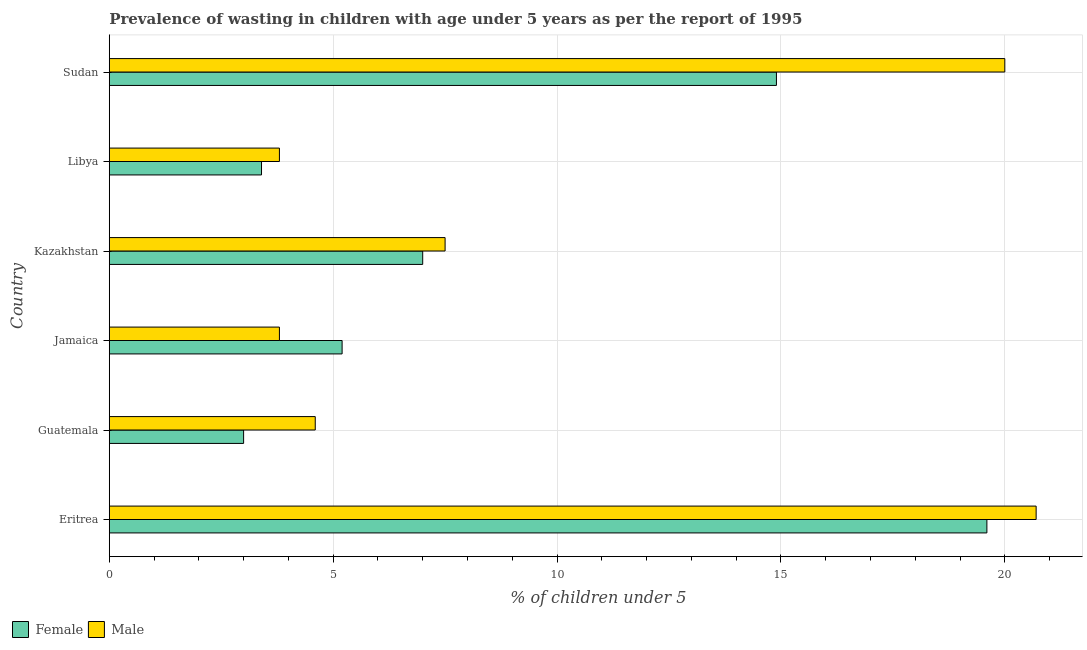Are the number of bars on each tick of the Y-axis equal?
Provide a succinct answer. Yes. How many bars are there on the 6th tick from the bottom?
Provide a succinct answer. 2. What is the label of the 2nd group of bars from the top?
Your answer should be compact. Libya. What is the percentage of undernourished male children in Jamaica?
Give a very brief answer. 3.8. Across all countries, what is the maximum percentage of undernourished male children?
Provide a short and direct response. 20.7. Across all countries, what is the minimum percentage of undernourished male children?
Your answer should be compact. 3.8. In which country was the percentage of undernourished male children maximum?
Provide a succinct answer. Eritrea. In which country was the percentage of undernourished female children minimum?
Ensure brevity in your answer.  Guatemala. What is the total percentage of undernourished male children in the graph?
Ensure brevity in your answer.  60.4. What is the difference between the percentage of undernourished male children in Jamaica and that in Sudan?
Keep it short and to the point. -16.2. What is the difference between the percentage of undernourished male children in Sudan and the percentage of undernourished female children in Libya?
Your answer should be very brief. 16.6. What is the average percentage of undernourished male children per country?
Make the answer very short. 10.07. In how many countries, is the percentage of undernourished female children greater than 4 %?
Provide a succinct answer. 4. What is the ratio of the percentage of undernourished female children in Libya to that in Sudan?
Give a very brief answer. 0.23. Is the percentage of undernourished female children in Eritrea less than that in Kazakhstan?
Provide a short and direct response. No. What is the difference between the highest and the lowest percentage of undernourished female children?
Your answer should be very brief. 16.6. Is the sum of the percentage of undernourished male children in Jamaica and Kazakhstan greater than the maximum percentage of undernourished female children across all countries?
Your answer should be compact. No. Are all the bars in the graph horizontal?
Provide a succinct answer. Yes. How many countries are there in the graph?
Offer a very short reply. 6. What is the difference between two consecutive major ticks on the X-axis?
Keep it short and to the point. 5. Are the values on the major ticks of X-axis written in scientific E-notation?
Give a very brief answer. No. Does the graph contain any zero values?
Offer a very short reply. No. Does the graph contain grids?
Provide a short and direct response. Yes. How many legend labels are there?
Give a very brief answer. 2. How are the legend labels stacked?
Your response must be concise. Horizontal. What is the title of the graph?
Ensure brevity in your answer.  Prevalence of wasting in children with age under 5 years as per the report of 1995. What is the label or title of the X-axis?
Your answer should be compact.  % of children under 5. What is the  % of children under 5 in Female in Eritrea?
Offer a very short reply. 19.6. What is the  % of children under 5 of Male in Eritrea?
Offer a very short reply. 20.7. What is the  % of children under 5 in Female in Guatemala?
Make the answer very short. 3. What is the  % of children under 5 of Male in Guatemala?
Give a very brief answer. 4.6. What is the  % of children under 5 of Female in Jamaica?
Offer a very short reply. 5.2. What is the  % of children under 5 of Male in Jamaica?
Offer a very short reply. 3.8. What is the  % of children under 5 in Female in Libya?
Provide a short and direct response. 3.4. What is the  % of children under 5 in Male in Libya?
Give a very brief answer. 3.8. What is the  % of children under 5 of Female in Sudan?
Make the answer very short. 14.9. What is the  % of children under 5 of Male in Sudan?
Keep it short and to the point. 20. Across all countries, what is the maximum  % of children under 5 in Female?
Keep it short and to the point. 19.6. Across all countries, what is the maximum  % of children under 5 of Male?
Offer a terse response. 20.7. Across all countries, what is the minimum  % of children under 5 in Female?
Provide a succinct answer. 3. Across all countries, what is the minimum  % of children under 5 of Male?
Make the answer very short. 3.8. What is the total  % of children under 5 of Female in the graph?
Ensure brevity in your answer.  53.1. What is the total  % of children under 5 of Male in the graph?
Your answer should be very brief. 60.4. What is the difference between the  % of children under 5 in Female in Eritrea and that in Jamaica?
Give a very brief answer. 14.4. What is the difference between the  % of children under 5 of Female in Eritrea and that in Libya?
Your response must be concise. 16.2. What is the difference between the  % of children under 5 of Male in Eritrea and that in Sudan?
Provide a short and direct response. 0.7. What is the difference between the  % of children under 5 in Female in Guatemala and that in Kazakhstan?
Provide a short and direct response. -4. What is the difference between the  % of children under 5 in Male in Guatemala and that in Kazakhstan?
Provide a short and direct response. -2.9. What is the difference between the  % of children under 5 in Female in Guatemala and that in Sudan?
Ensure brevity in your answer.  -11.9. What is the difference between the  % of children under 5 in Male in Guatemala and that in Sudan?
Your response must be concise. -15.4. What is the difference between the  % of children under 5 of Male in Jamaica and that in Libya?
Your response must be concise. 0. What is the difference between the  % of children under 5 of Female in Jamaica and that in Sudan?
Keep it short and to the point. -9.7. What is the difference between the  % of children under 5 in Male in Jamaica and that in Sudan?
Your response must be concise. -16.2. What is the difference between the  % of children under 5 in Male in Kazakhstan and that in Libya?
Your answer should be compact. 3.7. What is the difference between the  % of children under 5 in Female in Kazakhstan and that in Sudan?
Provide a succinct answer. -7.9. What is the difference between the  % of children under 5 of Female in Libya and that in Sudan?
Your response must be concise. -11.5. What is the difference between the  % of children under 5 in Male in Libya and that in Sudan?
Provide a succinct answer. -16.2. What is the difference between the  % of children under 5 in Female in Eritrea and the  % of children under 5 in Male in Guatemala?
Make the answer very short. 15. What is the difference between the  % of children under 5 of Female in Eritrea and the  % of children under 5 of Male in Jamaica?
Your answer should be compact. 15.8. What is the difference between the  % of children under 5 in Female in Eritrea and the  % of children under 5 in Male in Kazakhstan?
Ensure brevity in your answer.  12.1. What is the difference between the  % of children under 5 in Female in Eritrea and the  % of children under 5 in Male in Libya?
Keep it short and to the point. 15.8. What is the difference between the  % of children under 5 of Female in Guatemala and the  % of children under 5 of Male in Jamaica?
Your answer should be very brief. -0.8. What is the difference between the  % of children under 5 in Female in Jamaica and the  % of children under 5 in Male in Kazakhstan?
Make the answer very short. -2.3. What is the difference between the  % of children under 5 in Female in Jamaica and the  % of children under 5 in Male in Libya?
Offer a terse response. 1.4. What is the difference between the  % of children under 5 of Female in Jamaica and the  % of children under 5 of Male in Sudan?
Make the answer very short. -14.8. What is the difference between the  % of children under 5 in Female in Kazakhstan and the  % of children under 5 in Male in Libya?
Your answer should be very brief. 3.2. What is the difference between the  % of children under 5 in Female in Libya and the  % of children under 5 in Male in Sudan?
Your answer should be very brief. -16.6. What is the average  % of children under 5 in Female per country?
Offer a terse response. 8.85. What is the average  % of children under 5 in Male per country?
Your answer should be compact. 10.07. What is the difference between the  % of children under 5 of Female and  % of children under 5 of Male in Eritrea?
Give a very brief answer. -1.1. What is the difference between the  % of children under 5 in Female and  % of children under 5 in Male in Guatemala?
Provide a succinct answer. -1.6. What is the difference between the  % of children under 5 in Female and  % of children under 5 in Male in Jamaica?
Keep it short and to the point. 1.4. What is the difference between the  % of children under 5 of Female and  % of children under 5 of Male in Sudan?
Your response must be concise. -5.1. What is the ratio of the  % of children under 5 in Female in Eritrea to that in Guatemala?
Offer a terse response. 6.53. What is the ratio of the  % of children under 5 of Male in Eritrea to that in Guatemala?
Offer a terse response. 4.5. What is the ratio of the  % of children under 5 of Female in Eritrea to that in Jamaica?
Your answer should be compact. 3.77. What is the ratio of the  % of children under 5 in Male in Eritrea to that in Jamaica?
Provide a short and direct response. 5.45. What is the ratio of the  % of children under 5 in Male in Eritrea to that in Kazakhstan?
Make the answer very short. 2.76. What is the ratio of the  % of children under 5 in Female in Eritrea to that in Libya?
Provide a succinct answer. 5.76. What is the ratio of the  % of children under 5 in Male in Eritrea to that in Libya?
Provide a short and direct response. 5.45. What is the ratio of the  % of children under 5 of Female in Eritrea to that in Sudan?
Keep it short and to the point. 1.32. What is the ratio of the  % of children under 5 in Male in Eritrea to that in Sudan?
Your answer should be very brief. 1.03. What is the ratio of the  % of children under 5 of Female in Guatemala to that in Jamaica?
Your response must be concise. 0.58. What is the ratio of the  % of children under 5 in Male in Guatemala to that in Jamaica?
Offer a very short reply. 1.21. What is the ratio of the  % of children under 5 of Female in Guatemala to that in Kazakhstan?
Offer a very short reply. 0.43. What is the ratio of the  % of children under 5 in Male in Guatemala to that in Kazakhstan?
Your answer should be compact. 0.61. What is the ratio of the  % of children under 5 in Female in Guatemala to that in Libya?
Make the answer very short. 0.88. What is the ratio of the  % of children under 5 of Male in Guatemala to that in Libya?
Provide a short and direct response. 1.21. What is the ratio of the  % of children under 5 in Female in Guatemala to that in Sudan?
Give a very brief answer. 0.2. What is the ratio of the  % of children under 5 of Male in Guatemala to that in Sudan?
Give a very brief answer. 0.23. What is the ratio of the  % of children under 5 of Female in Jamaica to that in Kazakhstan?
Provide a succinct answer. 0.74. What is the ratio of the  % of children under 5 of Male in Jamaica to that in Kazakhstan?
Provide a succinct answer. 0.51. What is the ratio of the  % of children under 5 in Female in Jamaica to that in Libya?
Provide a short and direct response. 1.53. What is the ratio of the  % of children under 5 of Female in Jamaica to that in Sudan?
Provide a short and direct response. 0.35. What is the ratio of the  % of children under 5 of Male in Jamaica to that in Sudan?
Your answer should be very brief. 0.19. What is the ratio of the  % of children under 5 of Female in Kazakhstan to that in Libya?
Ensure brevity in your answer.  2.06. What is the ratio of the  % of children under 5 in Male in Kazakhstan to that in Libya?
Offer a terse response. 1.97. What is the ratio of the  % of children under 5 in Female in Kazakhstan to that in Sudan?
Keep it short and to the point. 0.47. What is the ratio of the  % of children under 5 in Male in Kazakhstan to that in Sudan?
Ensure brevity in your answer.  0.38. What is the ratio of the  % of children under 5 of Female in Libya to that in Sudan?
Keep it short and to the point. 0.23. What is the ratio of the  % of children under 5 of Male in Libya to that in Sudan?
Offer a terse response. 0.19. What is the difference between the highest and the lowest  % of children under 5 of Female?
Keep it short and to the point. 16.6. What is the difference between the highest and the lowest  % of children under 5 of Male?
Ensure brevity in your answer.  16.9. 